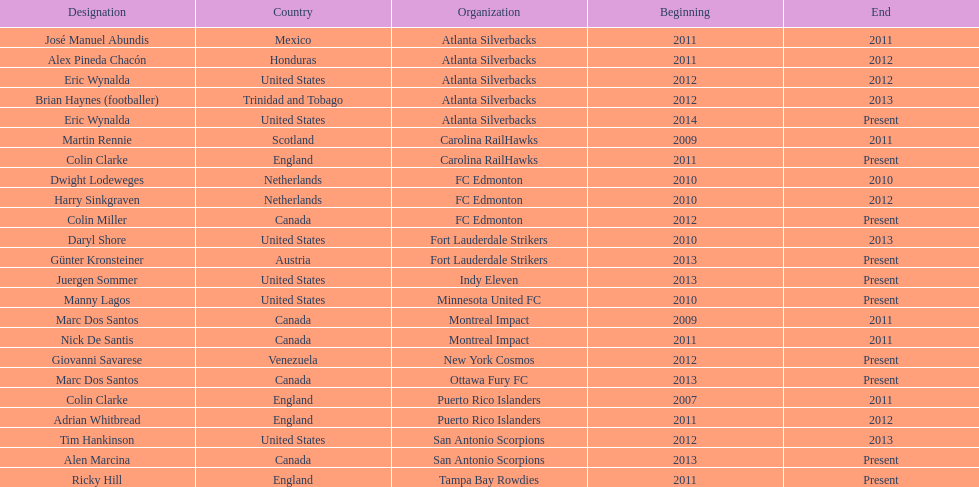How long did colin clarke coach the puerto rico islanders? 4 years. 